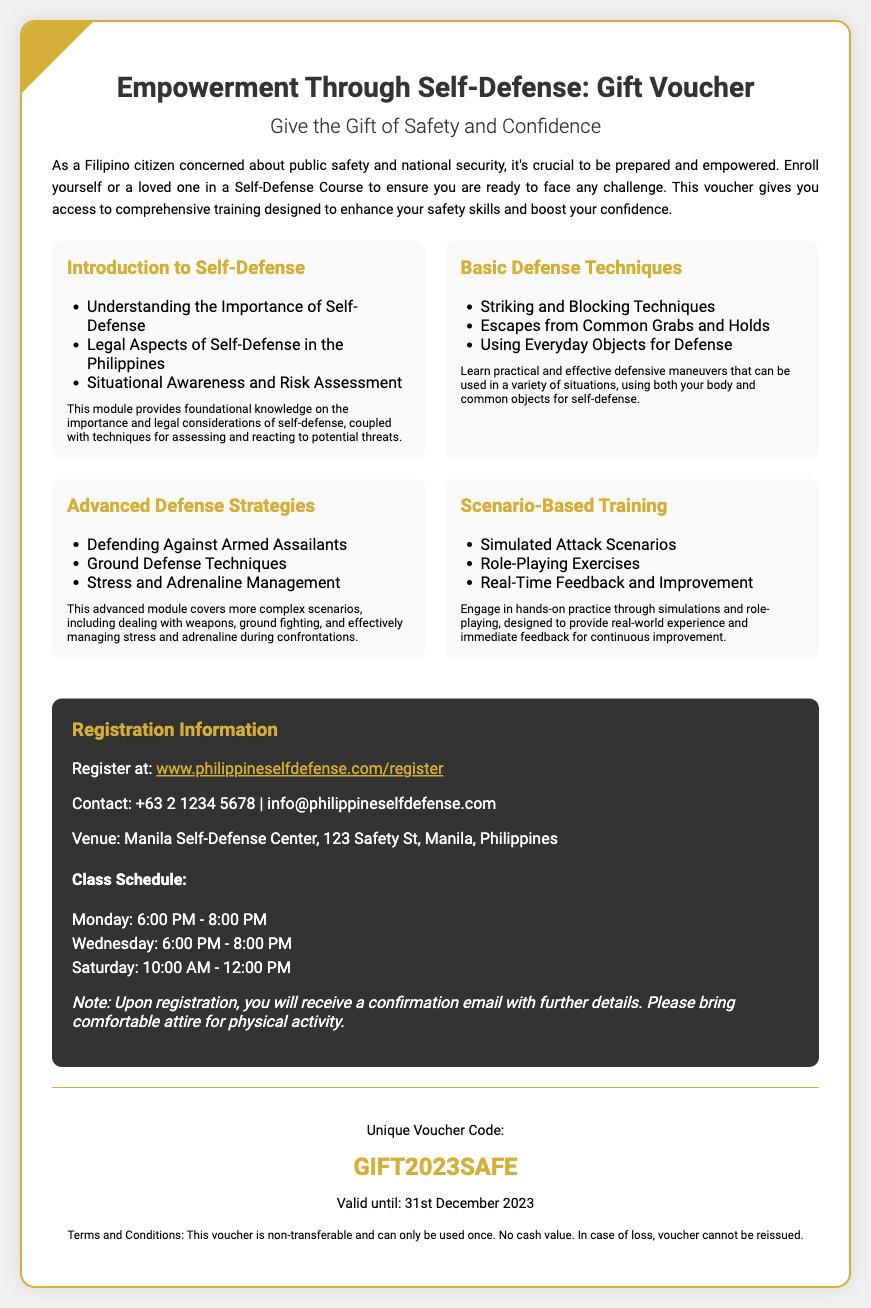What is the title of the voucher? The title is prominently displayed at the top of the document, which provides the main purpose of the voucher.
Answer: Empowerment Through Self-Defense: Gift Voucher What is the unique voucher code? The unique voucher code is typically found in a specific section of the document, designated for reference when redeeming the voucher.
Answer: GIFT2023SAFE When does the voucher expire? The expiration date is mentioned at the bottom of the voucher details, indicating the validity period of the voucher.
Answer: 31st December 2023 What is the contact number for inquiries? A specific contact method is provided in the registration information section for participants to reach out for more details.
Answer: +63 2 1234 5678 What is one topic covered in the "Basic Defense Techniques" module? Each module lists various topics, and the document specifies the subjects that will be covered under this category.
Answer: Striking and Blocking Techniques How many days a week are classes held? The registration information section outlines the class schedule and mentions the days classes are conducted.
Answer: Three days Where is the venue for the classes? The location for the self-defense classes is detailed in the registration information segment, where the venue is specified.
Answer: Manila Self-Defense Center, 123 Safety St, Manila, Philippines What is a note mentioned regarding attire for the class? Important details related to class preparation are included and provide insights into what participants should wear.
Answer: Bring comfortable attire for physical activity What type of training is mentioned in the "Scenario-Based Training" module? This section describes the nature of training involved, focusing on practical experience.
Answer: Simulated Attack Scenarios 